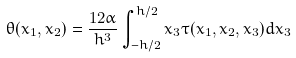Convert formula to latex. <formula><loc_0><loc_0><loc_500><loc_500>\theta ( x _ { 1 } , x _ { 2 } ) = \frac { 1 2 \alpha } { h ^ { 3 } } \int _ { - h / 2 } ^ { h / 2 } x _ { 3 } \tau ( x _ { 1 } , x _ { 2 } , x _ { 3 } ) d x _ { 3 }</formula> 